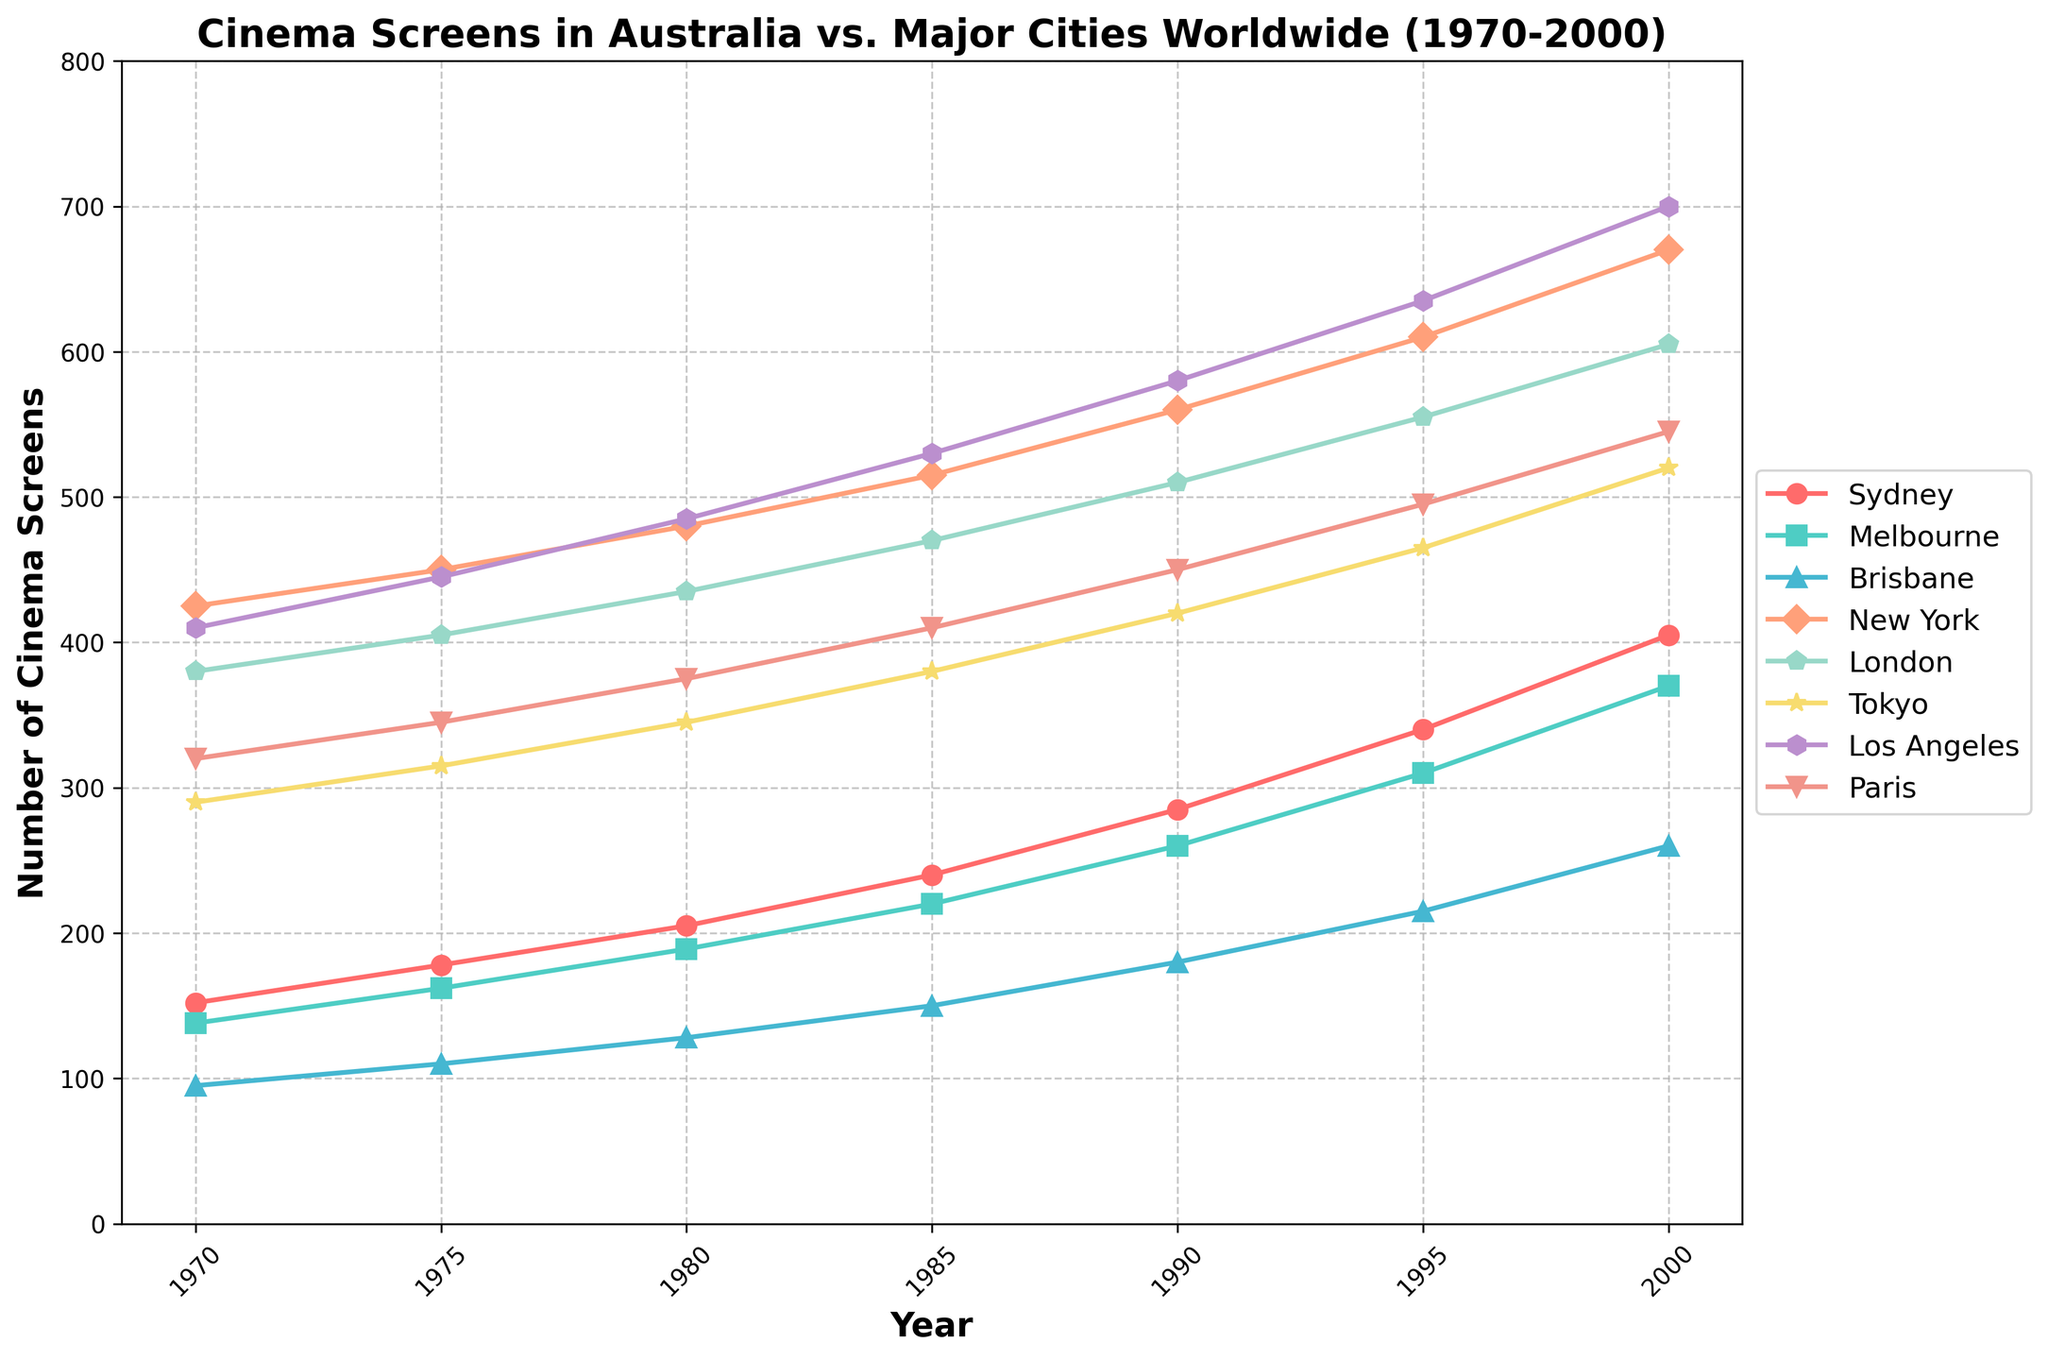What's the average number of cinema screens in Sydney from 1970 to 2000? To calculate the average number of cinema screens in Sydney, sum the values for each year and divide by the total number of years. The sum is 152 + 178 + 205 + 240 + 285 + 340 + 405 = 1805. There are 7 years, so the average is 1805 / 7 = 257.86
Answer: 257.86 Between 1980 and 1990, which city saw the largest increase in the number of cinema screens? Calculate the difference in the number of cinema screens for each city between 1980 and 1990. Sydney: 285-205=80, Melbourne: 260-189=71, Brisbane: 180-128=52, New York: 560-480=80, London: 510-435=75, Tokyo: 420-345=75, Los Angeles: 580-485=95, Paris: 450-375=75. Los Angeles saw the largest increase.
Answer: Los Angeles Which city had the highest number of cinema screens in 2000? Look at the figures for the year 2000. Sydney: 405, Melbourne: 370, Brisbane: 260, New York: 670, London: 605, Tokyo: 520, Los Angeles: 700, Paris: 545. The highest number was in Los Angeles.
Answer: Los Angeles How many more cinema screens were there in New York than in Sydney in 1985? Subtract the number of cinema screens in Sydney from New York in 1985. New York: 515, Sydney: 240. The difference is 515 - 240 = 275.
Answer: 275 What was the average number of cinema screens in Australian cities (Sydney, Melbourne, Brisbane) in 1995? Sum the number of cinema screens in Sydney, Melbourne, and Brisbane in 1995 and divide by 3. Sydney: 340, Melbourne: 310, Brisbane: 215. Sum: 340 + 310 + 215 = 865. Average: 865 / 3 = 288.33
Answer: 288.33 Which city had the least number of cinema screens in 1975 and how many? Look at the figures for each city in 1975. Sydney: 178, Melbourne: 162, Brisbane: 110, New York: 450, London: 405, Tokyo: 315, Los Angeles: 445, Paris: 345. The least number was in Brisbane with 110 screens.
Answer: Brisbane, 110 Did Tokyo or London have more cinema screens in 1990, and by how much? Compare the figures for Tokyo and London in 1990. Tokyo: 420, London: 510. London had more screens by 510 - 420 = 90.
Answer: London, 90 What's the difference in the total number of cinema screens in Australian cities versus Los Angeles in the year 2000? Sum the number of cinema screens in Sydney, Melbourne, and Brisbane and subtract the total from the number in Los Angeles in 2000. Sydney: 405, Melbourne: 370, Brisbane: 260, Los Angeles: 700. Sum of Australian cities: 405 + 370 + 260 = 1035. Difference: 1035 - 700 = 335.
Answer: 335 